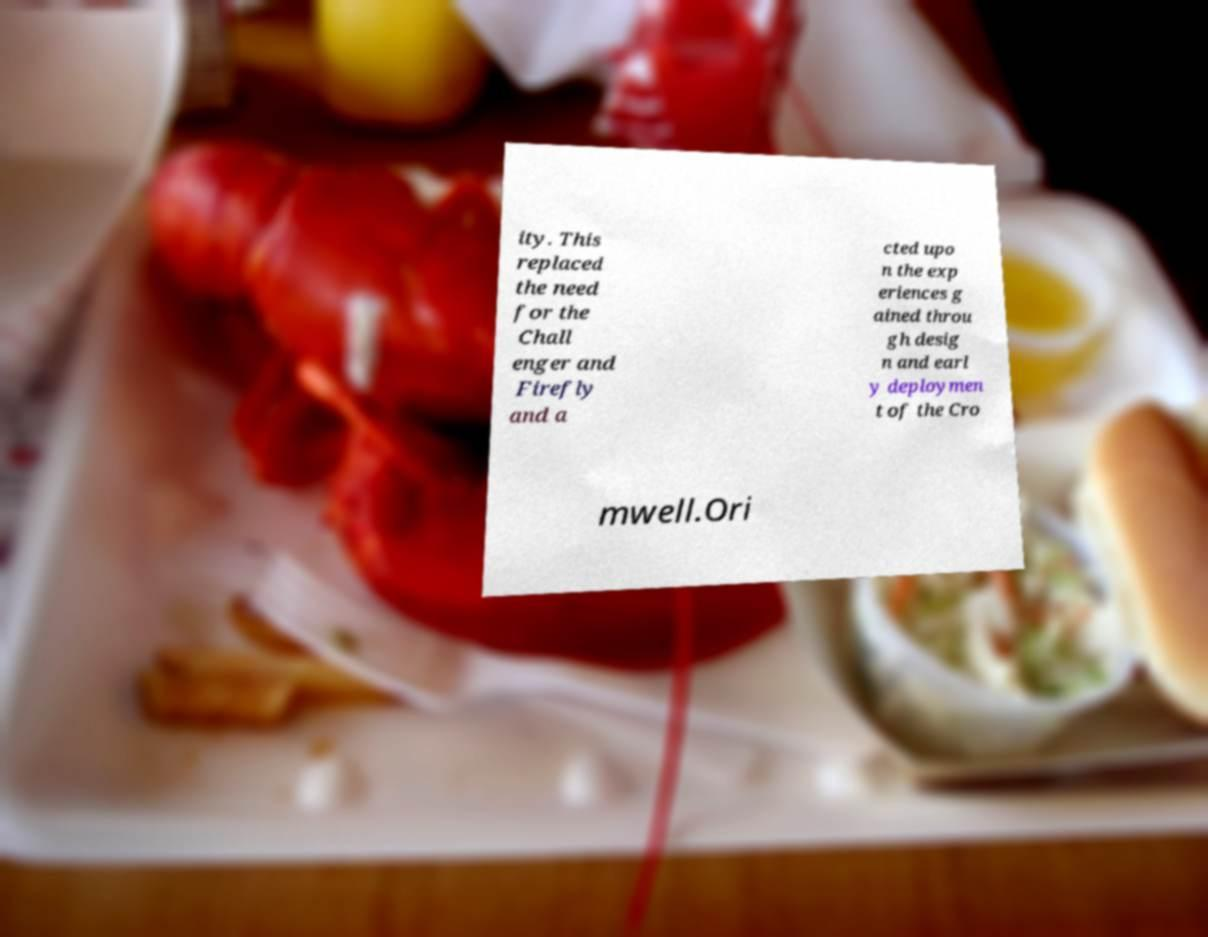For documentation purposes, I need the text within this image transcribed. Could you provide that? ity. This replaced the need for the Chall enger and Firefly and a cted upo n the exp eriences g ained throu gh desig n and earl y deploymen t of the Cro mwell.Ori 